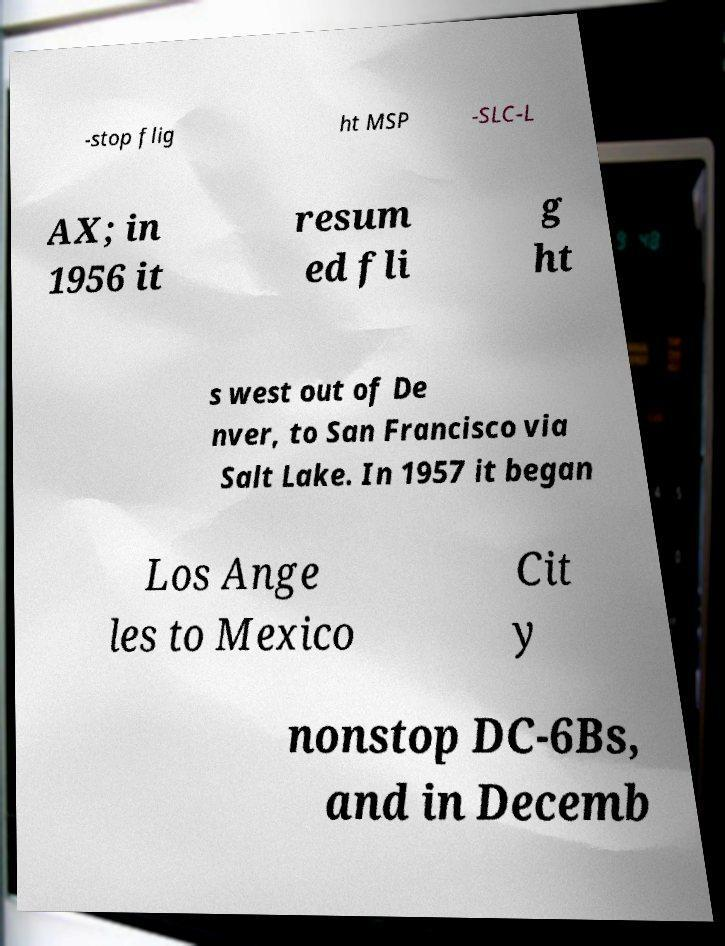Can you read and provide the text displayed in the image?This photo seems to have some interesting text. Can you extract and type it out for me? -stop flig ht MSP -SLC-L AX; in 1956 it resum ed fli g ht s west out of De nver, to San Francisco via Salt Lake. In 1957 it began Los Ange les to Mexico Cit y nonstop DC-6Bs, and in Decemb 